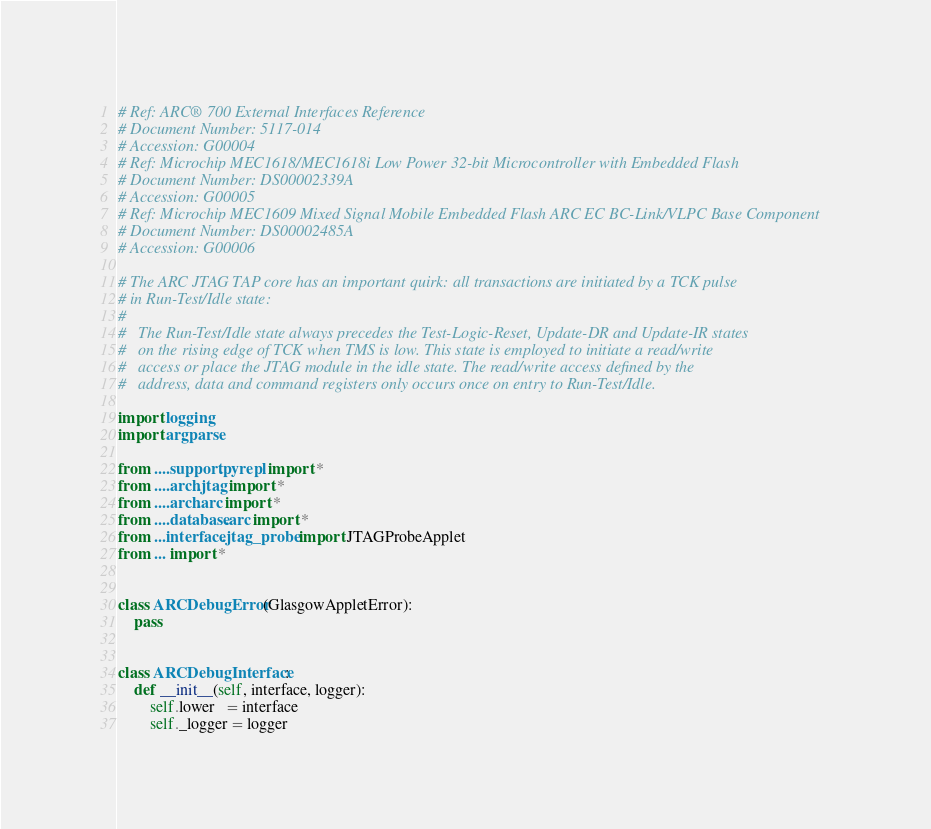<code> <loc_0><loc_0><loc_500><loc_500><_Python_># Ref: ARC® 700 External Interfaces Reference
# Document Number: 5117-014
# Accession: G00004
# Ref: Microchip MEC1618/MEC1618i Low Power 32-bit Microcontroller with Embedded Flash
# Document Number: DS00002339A
# Accession: G00005
# Ref: Microchip MEC1609 Mixed Signal Mobile Embedded Flash ARC EC BC-Link/VLPC Base Component
# Document Number: DS00002485A
# Accession: G00006

# The ARC JTAG TAP core has an important quirk: all transactions are initiated by a TCK pulse
# in Run-Test/Idle state:
#
#   The Run-Test/Idle state always precedes the Test-Logic-Reset, Update-DR and Update-IR states
#   on the rising edge of TCK when TMS is low. This state is employed to initiate a read/write
#   access or place the JTAG module in the idle state. The read/write access defined by the
#   address, data and command registers only occurs once on entry to Run-Test/Idle.

import logging
import argparse

from ....support.pyrepl import *
from ....arch.jtag import *
from ....arch.arc import *
from ....database.arc import *
from ...interface.jtag_probe import JTAGProbeApplet
from ... import *


class ARCDebugError(GlasgowAppletError):
    pass


class ARCDebugInterface:
    def __init__(self, interface, logger):
        self.lower   = interface
        self._logger = logger</code> 